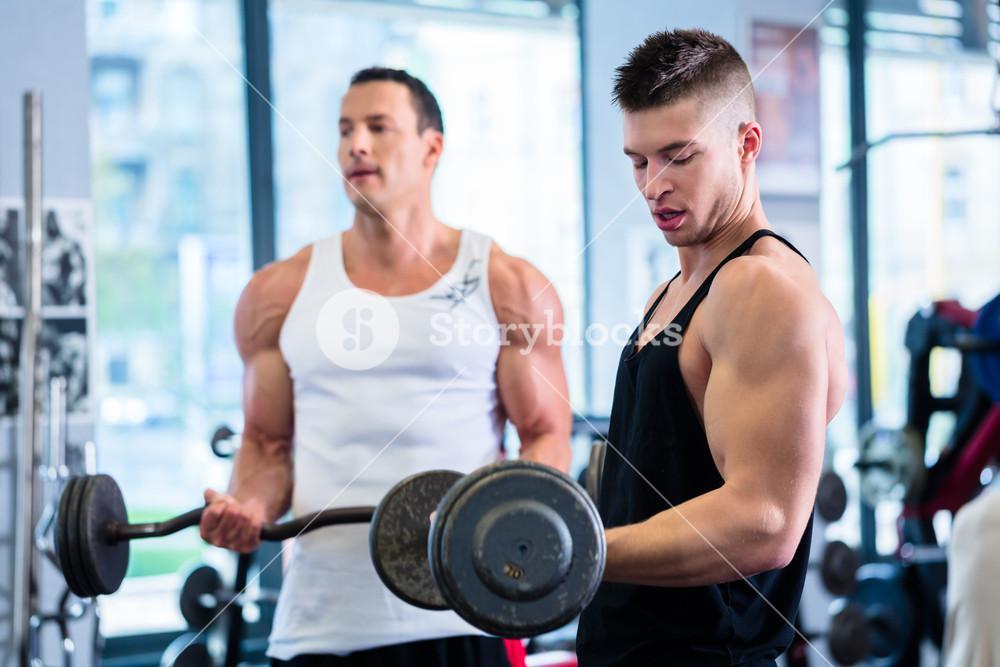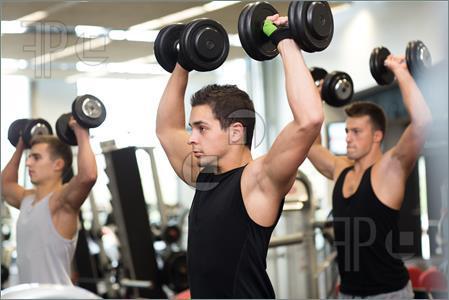The first image is the image on the left, the second image is the image on the right. Assess this claim about the two images: "The left and right image contains a total of five people lifting weights.". Correct or not? Answer yes or no. Yes. The first image is the image on the left, the second image is the image on the right. For the images displayed, is the sentence "The right image includes two people sitting facing forward, each with one dumbbell in a lowered hand and one in a raised hand." factually correct? Answer yes or no. No. 